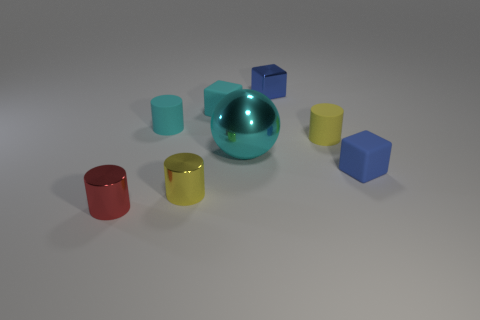What could be the possible size of these objects? The sizes of the objects are not definite without a reference, but based on their proportions relative to each other, the cyan sphere appears to be the largest. The cubes and cylinders could be similarly sized, potentially small enough to hold in one hand. 